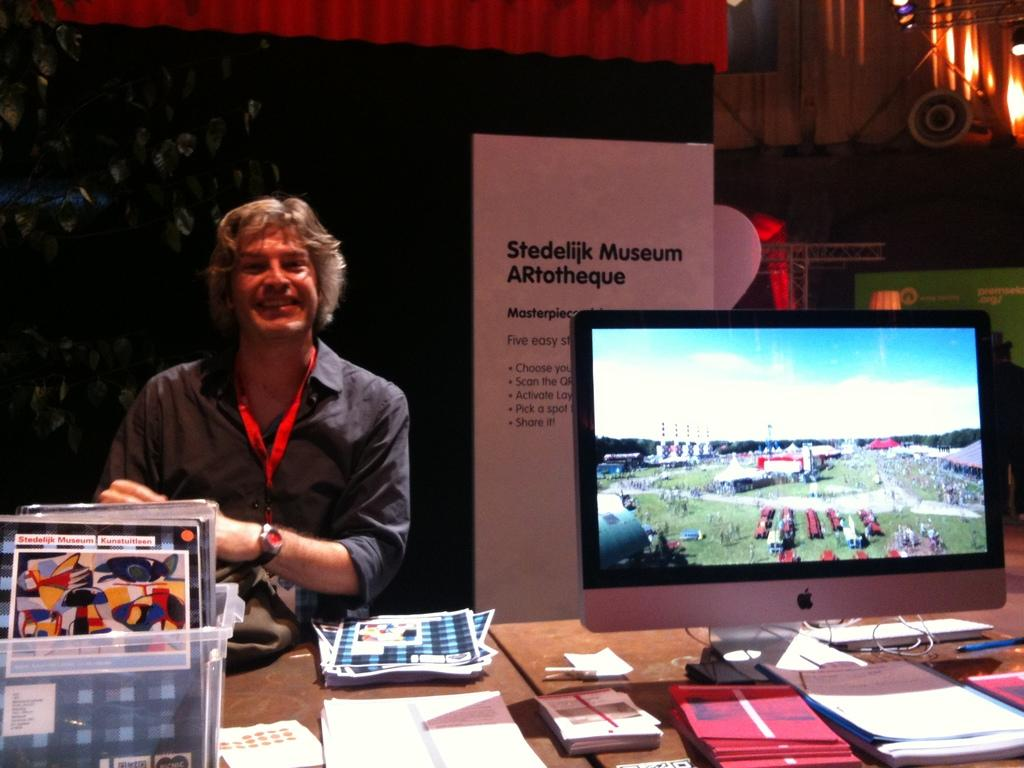Provide a one-sentence caption for the provided image. A man is smiling behind a booth with an Apple monitor at the Stedilijk Museum Artotheque. 